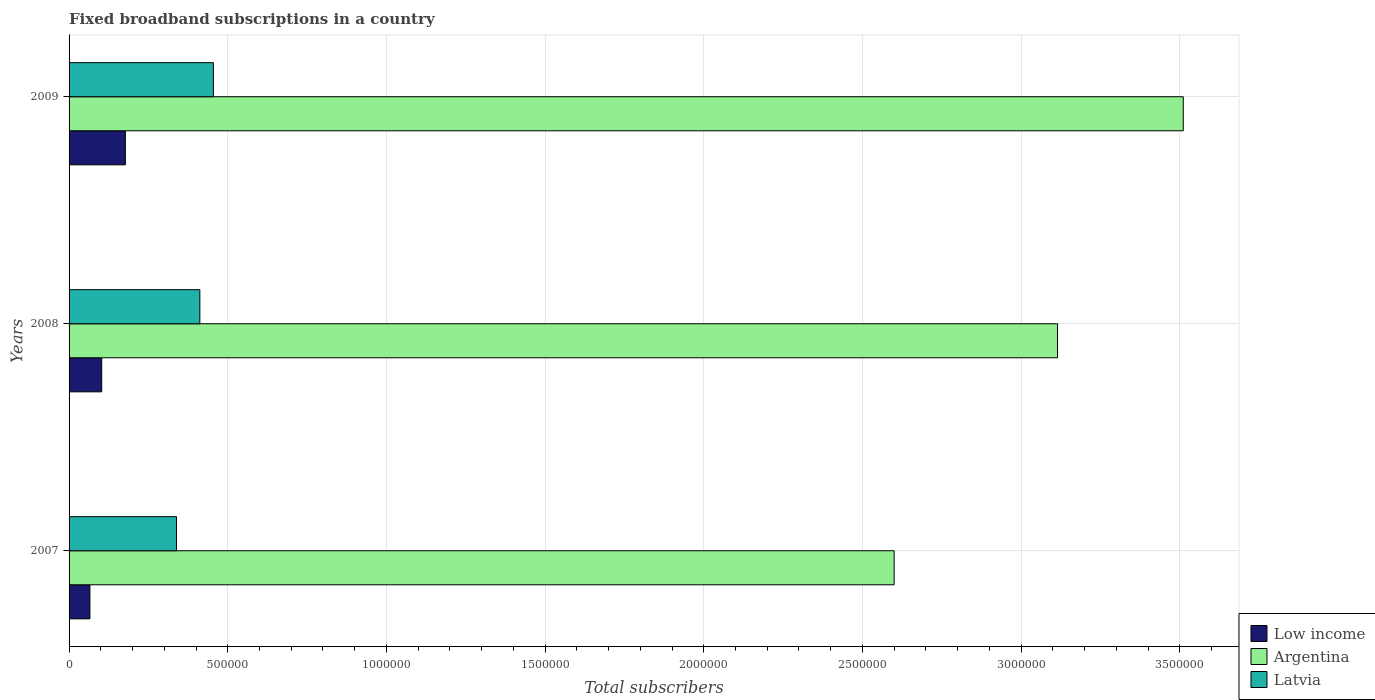How many different coloured bars are there?
Your response must be concise. 3. How many groups of bars are there?
Keep it short and to the point. 3. Are the number of bars on each tick of the Y-axis equal?
Make the answer very short. Yes. How many bars are there on the 1st tick from the top?
Your answer should be very brief. 3. What is the label of the 2nd group of bars from the top?
Your answer should be compact. 2008. In how many cases, is the number of bars for a given year not equal to the number of legend labels?
Your answer should be compact. 0. What is the number of broadband subscriptions in Latvia in 2009?
Your answer should be very brief. 4.55e+05. Across all years, what is the maximum number of broadband subscriptions in Low income?
Your answer should be very brief. 1.77e+05. Across all years, what is the minimum number of broadband subscriptions in Argentina?
Give a very brief answer. 2.60e+06. In which year was the number of broadband subscriptions in Latvia minimum?
Give a very brief answer. 2007. What is the total number of broadband subscriptions in Latvia in the graph?
Offer a very short reply. 1.21e+06. What is the difference between the number of broadband subscriptions in Latvia in 2007 and that in 2009?
Ensure brevity in your answer.  -1.16e+05. What is the difference between the number of broadband subscriptions in Argentina in 2009 and the number of broadband subscriptions in Latvia in 2008?
Your answer should be very brief. 3.10e+06. What is the average number of broadband subscriptions in Latvia per year?
Offer a very short reply. 4.02e+05. In the year 2007, what is the difference between the number of broadband subscriptions in Argentina and number of broadband subscriptions in Latvia?
Provide a succinct answer. 2.26e+06. What is the ratio of the number of broadband subscriptions in Low income in 2008 to that in 2009?
Your answer should be very brief. 0.58. What is the difference between the highest and the second highest number of broadband subscriptions in Argentina?
Your answer should be very brief. 3.96e+05. What is the difference between the highest and the lowest number of broadband subscriptions in Argentina?
Your response must be concise. 9.11e+05. In how many years, is the number of broadband subscriptions in Latvia greater than the average number of broadband subscriptions in Latvia taken over all years?
Provide a short and direct response. 2. What does the 2nd bar from the top in 2009 represents?
Your response must be concise. Argentina. What does the 1st bar from the bottom in 2007 represents?
Offer a terse response. Low income. Are all the bars in the graph horizontal?
Keep it short and to the point. Yes. What is the difference between two consecutive major ticks on the X-axis?
Make the answer very short. 5.00e+05. Are the values on the major ticks of X-axis written in scientific E-notation?
Offer a very short reply. No. Does the graph contain any zero values?
Provide a short and direct response. No. Where does the legend appear in the graph?
Offer a very short reply. Bottom right. How many legend labels are there?
Your answer should be compact. 3. What is the title of the graph?
Give a very brief answer. Fixed broadband subscriptions in a country. What is the label or title of the X-axis?
Offer a terse response. Total subscribers. What is the Total subscribers in Low income in 2007?
Your answer should be compact. 6.57e+04. What is the Total subscribers of Argentina in 2007?
Keep it short and to the point. 2.60e+06. What is the Total subscribers in Latvia in 2007?
Offer a terse response. 3.39e+05. What is the Total subscribers of Low income in 2008?
Your answer should be very brief. 1.03e+05. What is the Total subscribers of Argentina in 2008?
Provide a succinct answer. 3.11e+06. What is the Total subscribers of Latvia in 2008?
Your response must be concise. 4.12e+05. What is the Total subscribers in Low income in 2009?
Offer a very short reply. 1.77e+05. What is the Total subscribers in Argentina in 2009?
Offer a terse response. 3.51e+06. What is the Total subscribers in Latvia in 2009?
Keep it short and to the point. 4.55e+05. Across all years, what is the maximum Total subscribers of Low income?
Give a very brief answer. 1.77e+05. Across all years, what is the maximum Total subscribers of Argentina?
Ensure brevity in your answer.  3.51e+06. Across all years, what is the maximum Total subscribers in Latvia?
Keep it short and to the point. 4.55e+05. Across all years, what is the minimum Total subscribers of Low income?
Offer a terse response. 6.57e+04. Across all years, what is the minimum Total subscribers in Argentina?
Ensure brevity in your answer.  2.60e+06. Across all years, what is the minimum Total subscribers in Latvia?
Give a very brief answer. 3.39e+05. What is the total Total subscribers in Low income in the graph?
Make the answer very short. 3.46e+05. What is the total Total subscribers of Argentina in the graph?
Your answer should be very brief. 9.23e+06. What is the total Total subscribers in Latvia in the graph?
Ensure brevity in your answer.  1.21e+06. What is the difference between the Total subscribers in Low income in 2007 and that in 2008?
Give a very brief answer. -3.72e+04. What is the difference between the Total subscribers in Argentina in 2007 and that in 2008?
Provide a short and direct response. -5.15e+05. What is the difference between the Total subscribers of Latvia in 2007 and that in 2008?
Provide a succinct answer. -7.35e+04. What is the difference between the Total subscribers in Low income in 2007 and that in 2009?
Your response must be concise. -1.12e+05. What is the difference between the Total subscribers in Argentina in 2007 and that in 2009?
Keep it short and to the point. -9.11e+05. What is the difference between the Total subscribers in Latvia in 2007 and that in 2009?
Provide a succinct answer. -1.16e+05. What is the difference between the Total subscribers in Low income in 2008 and that in 2009?
Keep it short and to the point. -7.46e+04. What is the difference between the Total subscribers of Argentina in 2008 and that in 2009?
Offer a very short reply. -3.96e+05. What is the difference between the Total subscribers of Latvia in 2008 and that in 2009?
Offer a very short reply. -4.26e+04. What is the difference between the Total subscribers in Low income in 2007 and the Total subscribers in Argentina in 2008?
Provide a succinct answer. -3.05e+06. What is the difference between the Total subscribers of Low income in 2007 and the Total subscribers of Latvia in 2008?
Your response must be concise. -3.46e+05. What is the difference between the Total subscribers of Argentina in 2007 and the Total subscribers of Latvia in 2008?
Make the answer very short. 2.19e+06. What is the difference between the Total subscribers in Low income in 2007 and the Total subscribers in Argentina in 2009?
Your response must be concise. -3.45e+06. What is the difference between the Total subscribers of Low income in 2007 and the Total subscribers of Latvia in 2009?
Provide a short and direct response. -3.89e+05. What is the difference between the Total subscribers in Argentina in 2007 and the Total subscribers in Latvia in 2009?
Your answer should be very brief. 2.15e+06. What is the difference between the Total subscribers in Low income in 2008 and the Total subscribers in Argentina in 2009?
Provide a short and direct response. -3.41e+06. What is the difference between the Total subscribers in Low income in 2008 and the Total subscribers in Latvia in 2009?
Ensure brevity in your answer.  -3.52e+05. What is the difference between the Total subscribers in Argentina in 2008 and the Total subscribers in Latvia in 2009?
Make the answer very short. 2.66e+06. What is the average Total subscribers in Low income per year?
Make the answer very short. 1.15e+05. What is the average Total subscribers of Argentina per year?
Offer a very short reply. 3.08e+06. What is the average Total subscribers of Latvia per year?
Offer a terse response. 4.02e+05. In the year 2007, what is the difference between the Total subscribers in Low income and Total subscribers in Argentina?
Your response must be concise. -2.53e+06. In the year 2007, what is the difference between the Total subscribers in Low income and Total subscribers in Latvia?
Your response must be concise. -2.73e+05. In the year 2007, what is the difference between the Total subscribers in Argentina and Total subscribers in Latvia?
Provide a short and direct response. 2.26e+06. In the year 2008, what is the difference between the Total subscribers of Low income and Total subscribers of Argentina?
Offer a terse response. -3.01e+06. In the year 2008, what is the difference between the Total subscribers of Low income and Total subscribers of Latvia?
Provide a short and direct response. -3.09e+05. In the year 2008, what is the difference between the Total subscribers of Argentina and Total subscribers of Latvia?
Give a very brief answer. 2.70e+06. In the year 2009, what is the difference between the Total subscribers in Low income and Total subscribers in Argentina?
Keep it short and to the point. -3.33e+06. In the year 2009, what is the difference between the Total subscribers in Low income and Total subscribers in Latvia?
Give a very brief answer. -2.77e+05. In the year 2009, what is the difference between the Total subscribers of Argentina and Total subscribers of Latvia?
Your response must be concise. 3.06e+06. What is the ratio of the Total subscribers in Low income in 2007 to that in 2008?
Give a very brief answer. 0.64. What is the ratio of the Total subscribers of Argentina in 2007 to that in 2008?
Keep it short and to the point. 0.83. What is the ratio of the Total subscribers in Latvia in 2007 to that in 2008?
Your response must be concise. 0.82. What is the ratio of the Total subscribers of Low income in 2007 to that in 2009?
Provide a short and direct response. 0.37. What is the ratio of the Total subscribers in Argentina in 2007 to that in 2009?
Make the answer very short. 0.74. What is the ratio of the Total subscribers of Latvia in 2007 to that in 2009?
Make the answer very short. 0.74. What is the ratio of the Total subscribers of Low income in 2008 to that in 2009?
Your response must be concise. 0.58. What is the ratio of the Total subscribers in Argentina in 2008 to that in 2009?
Your answer should be compact. 0.89. What is the ratio of the Total subscribers of Latvia in 2008 to that in 2009?
Make the answer very short. 0.91. What is the difference between the highest and the second highest Total subscribers in Low income?
Provide a short and direct response. 7.46e+04. What is the difference between the highest and the second highest Total subscribers in Argentina?
Make the answer very short. 3.96e+05. What is the difference between the highest and the second highest Total subscribers in Latvia?
Provide a short and direct response. 4.26e+04. What is the difference between the highest and the lowest Total subscribers of Low income?
Your response must be concise. 1.12e+05. What is the difference between the highest and the lowest Total subscribers in Argentina?
Provide a succinct answer. 9.11e+05. What is the difference between the highest and the lowest Total subscribers in Latvia?
Offer a terse response. 1.16e+05. 